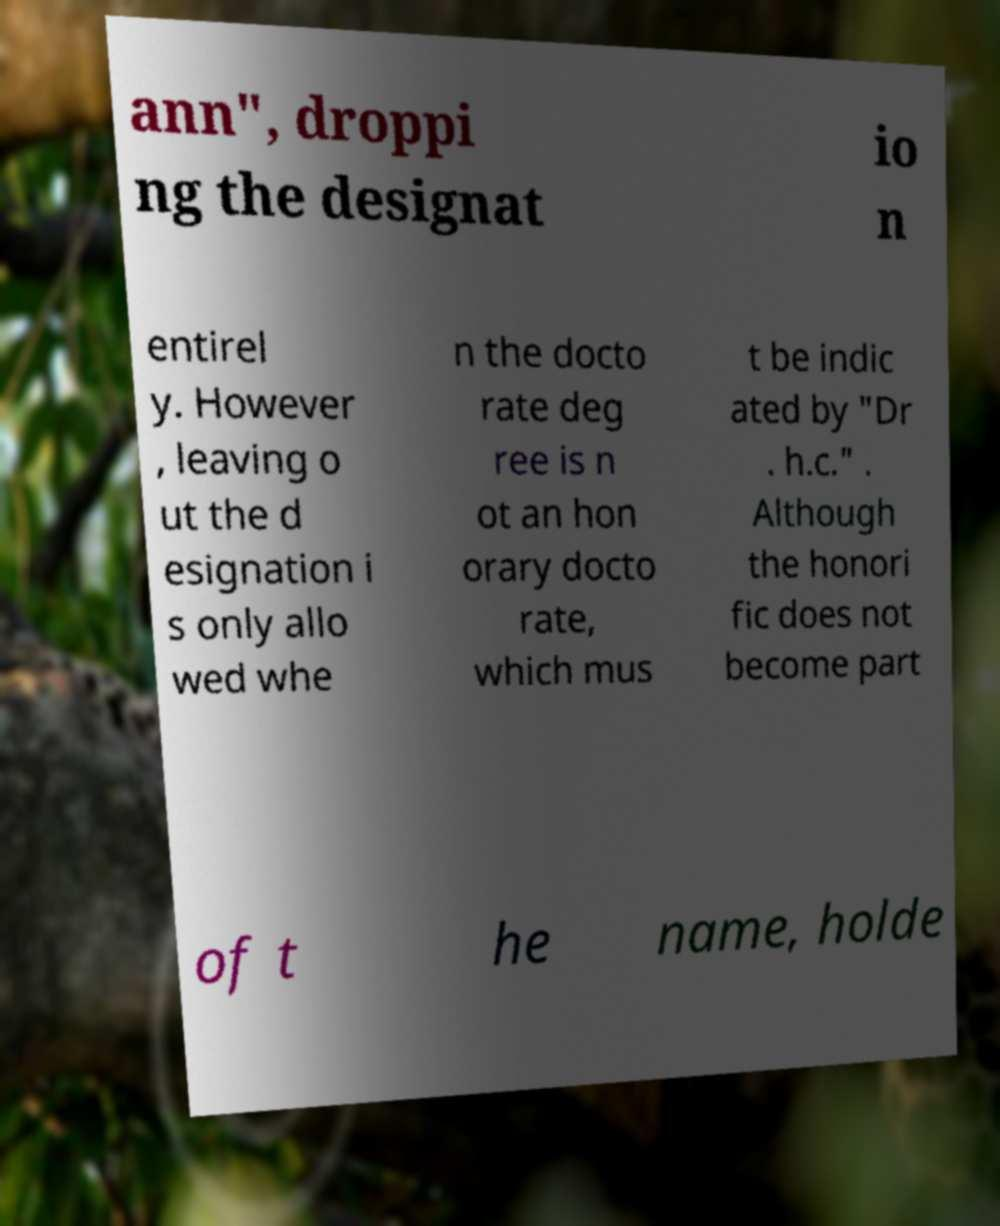There's text embedded in this image that I need extracted. Can you transcribe it verbatim? ann", droppi ng the designat io n entirel y. However , leaving o ut the d esignation i s only allo wed whe n the docto rate deg ree is n ot an hon orary docto rate, which mus t be indic ated by "Dr . h.c." . Although the honori fic does not become part of t he name, holde 